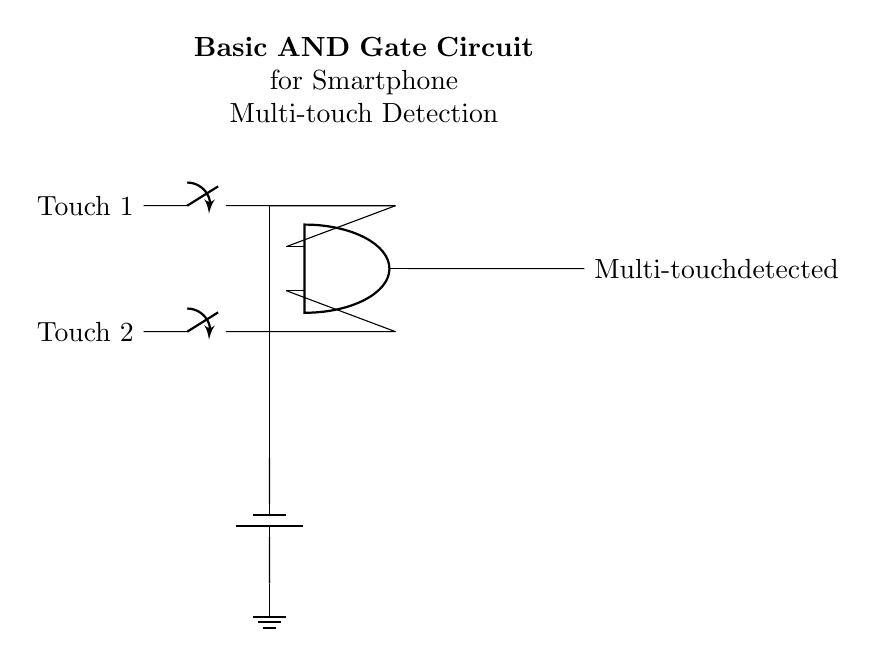What components are used in this circuit? The circuit uses two switches, an AND gate, and a battery. These components are visible in the diagram: the switches are labeled "Touch 1" and "Touch 2," indicating their function in touch detection, while the AND gate combines the inputs.
Answer: two switches, AND gate, battery What does the output indicate in this circuit? The output of the circuit is labeled "Multi-touch detected," which informs us that the AND gate will only output a signal when both touch inputs are activated. This reflects the circuit's function to confirm simultaneous interactions.
Answer: Multi-touch detected How many inputs does the AND gate have? The AND gate in the circuit has two inputs, as shown by the two connections leading into the gate from the switches labeled "Touch 1" and "Touch 2." This is characteristic of a basic AND gate, which requires all inputs to be true for the output to activate.
Answer: two What is needed for the AND gate to output a signal? For the AND gate to output a signal, both inputs (Touch 1 and Touch 2) must be activated at the same time. This is a fundamental property of AND gates, which only produce a high output when all inputs are high (active).
Answer: Both inputs must be activated What purpose does the battery serve in this circuit? The battery provides electrical power to the circuit, enabling the switches and the AND gate to operate. It connects to the top of the circuit and is necessary for the entire system to function, supplying the voltage required for detection.
Answer: Power supply 